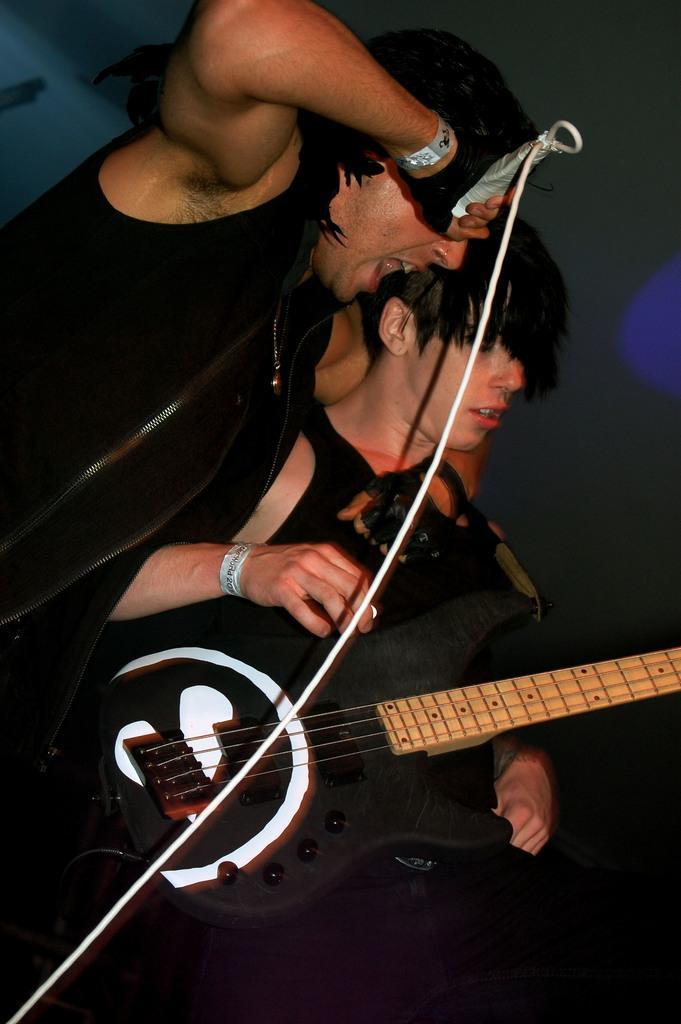Can you describe this image briefly? In the picture there are two men, first person is holding mike with his right hand and singing , the second person is holding guitar with his hand and playing the guitar, both of them wearing black color shirts in the background there is a grey color wall. 